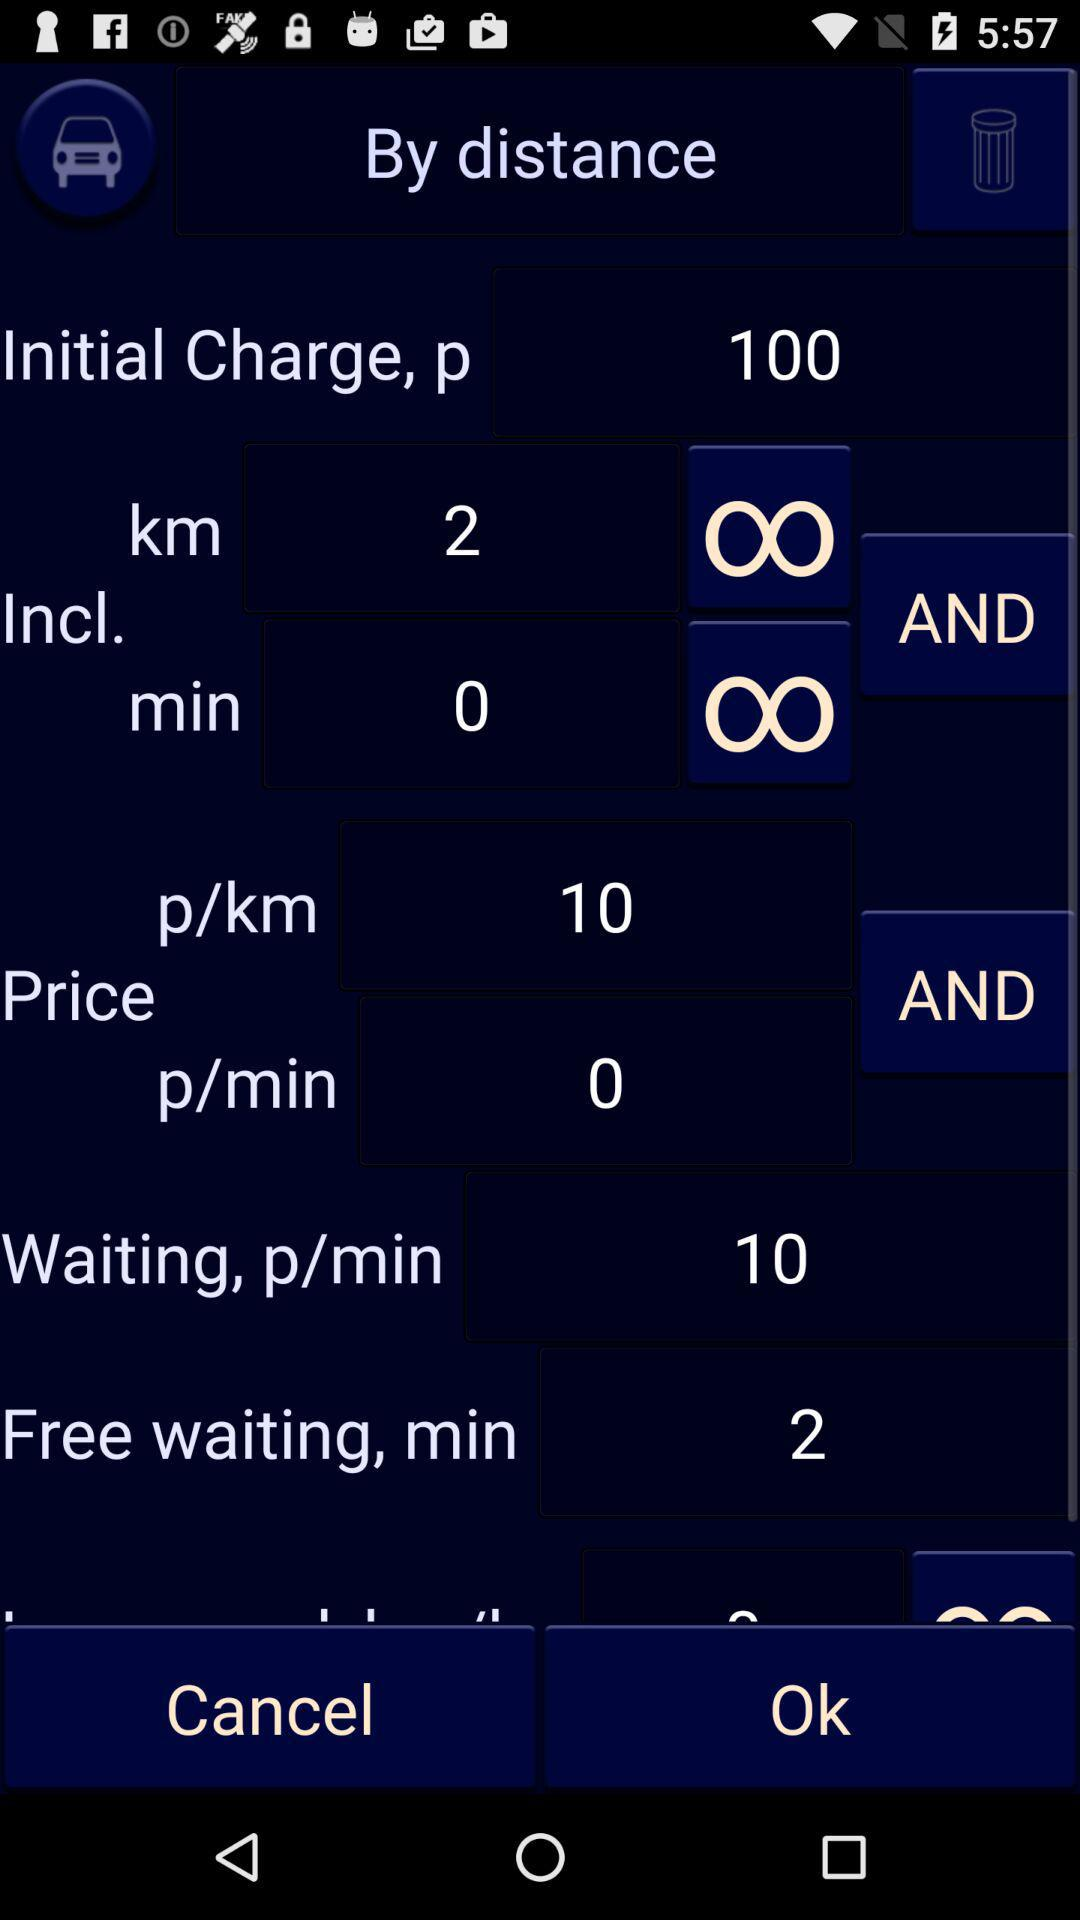How many minutes of free waiting are offered?
Answer the question using a single word or phrase. 2 